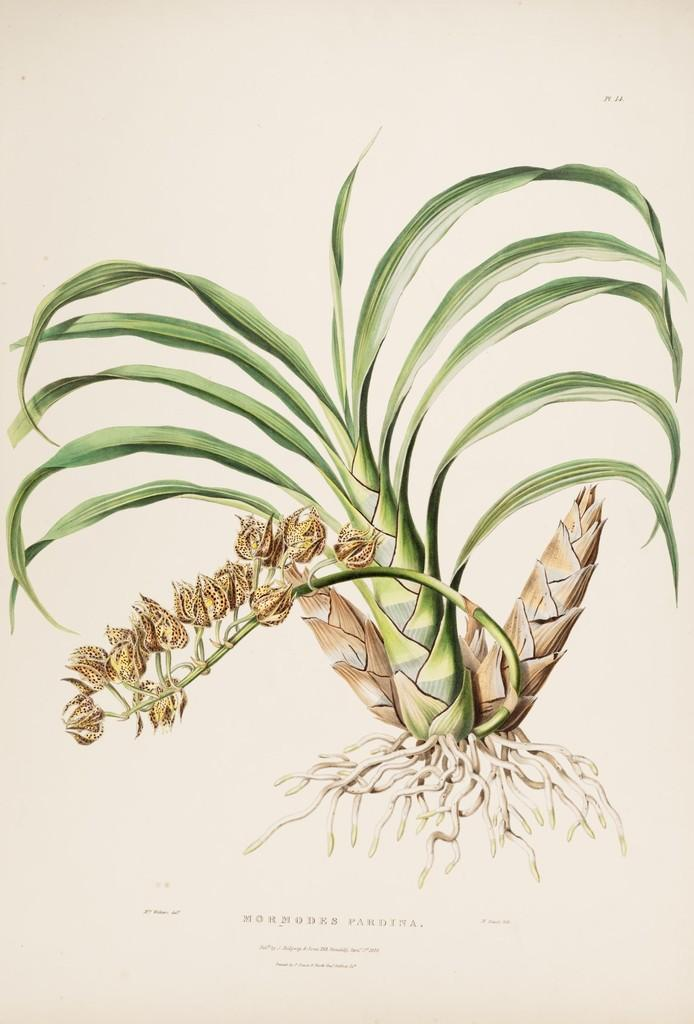What is on the paper in the image? There is a painting on the paper. What does the painting depict? The painting depicts a plant. Can you describe the plant in the painting? The plant has roots and seeds. What invention is being showcased in the park in the image? There is no park or invention present in the image; it features a painting of a plant on paper. What attraction can be seen in the image? The image does not depict an attraction; it features a painting of a plant on paper. 